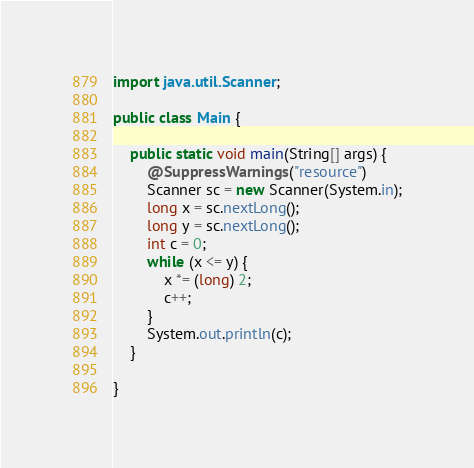<code> <loc_0><loc_0><loc_500><loc_500><_Java_>import java.util.Scanner;

public class Main {

    public static void main(String[] args) {
        @SuppressWarnings("resource")
        Scanner sc = new Scanner(System.in);
        long x = sc.nextLong();
        long y = sc.nextLong();
        int c = 0;
        while (x <= y) {
            x *= (long) 2;
            c++;
        }
        System.out.println(c);
    }

}
</code> 